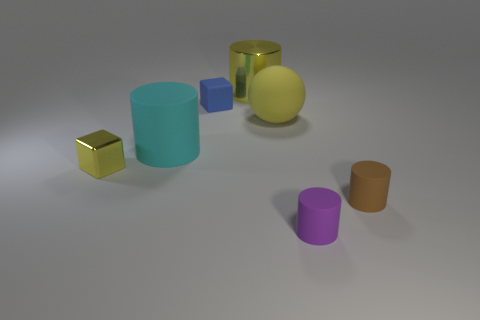Subtract all small brown matte cylinders. How many cylinders are left? 3 Subtract all purple cylinders. How many cylinders are left? 3 Add 3 cyan cylinders. How many objects exist? 10 Subtract 2 cylinders. How many cylinders are left? 2 Subtract all cubes. How many objects are left? 5 Subtract all blue cylinders. Subtract all cyan spheres. How many cylinders are left? 4 Add 7 small cylinders. How many small cylinders are left? 9 Add 5 green matte cubes. How many green matte cubes exist? 5 Subtract 0 green cylinders. How many objects are left? 7 Subtract all big yellow objects. Subtract all large yellow rubber balls. How many objects are left? 4 